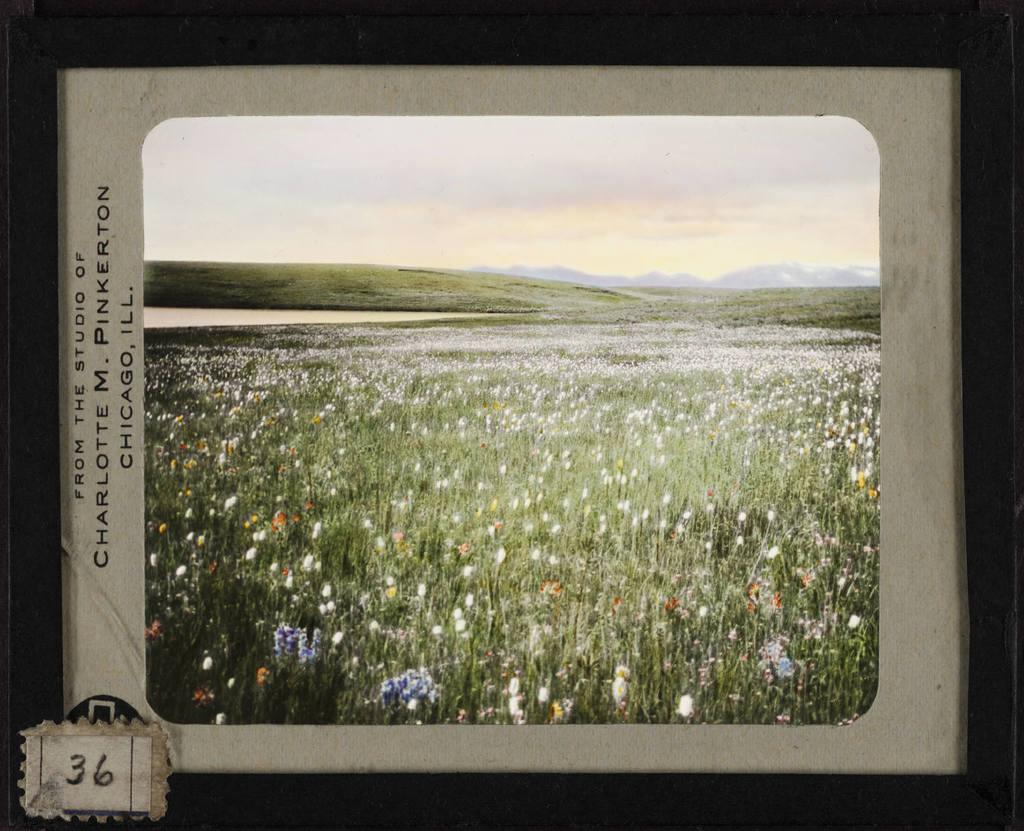<image>
Relay a brief, clear account of the picture shown. A picture of a field from the studio of Charlotte M. Pinkerton 